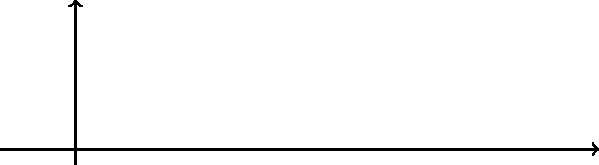Based on the graph showing the accuracy of two COVID-19 X-ray classification models as the number of convolutional layers increases, which model demonstrates better performance for detecting COVID-19 in chest X-rays, and what critical factor should be considered when implementing such a system in Belarus? To answer this question, let's analyze the graph step-by-step:

1. The graph shows the accuracy of two models (A and B) for classifying COVID-19 X-ray images as the number of convolutional layers increases.

2. Model A (blue line):
   - Starts at 0.75 accuracy with 0 convolutional layers
   - Reaches 0.92 accuracy with 3 convolutional layers

3. Model B (red line):
   - Starts at 0.70 accuracy with 0 convolutional layers
   - Reaches 0.87 accuracy with 3 convolutional layers

4. Comparing the two models:
   - Model A consistently shows higher accuracy across all layer configurations
   - The gap between Model A and Model B remains relatively constant

5. Model A demonstrates better performance for detecting COVID-19 in chest X-rays, as it achieves higher accuracy with the same number of convolutional layers.

6. Critical factor to consider when implementing such a system in Belarus:
   - While accuracy is important, transparency in the model's decision-making process is crucial for public trust and ethical considerations.
   - Explainable AI techniques should be incorporated to provide interpretable results, allowing medical professionals and patients to understand the basis for the model's classifications.
   - This aligns with the persona's value of transparency in public health crisis responses.
Answer: Model A; transparency in decision-making process 